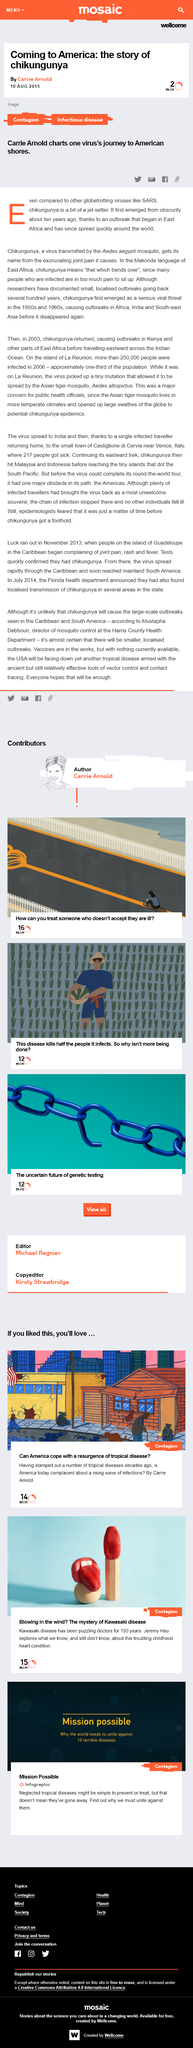Point out several critical features in this image. Chikungunya virus first emerged in East Africa, according to historical records. Carrie Arnold wrote an article about chikungunya. 